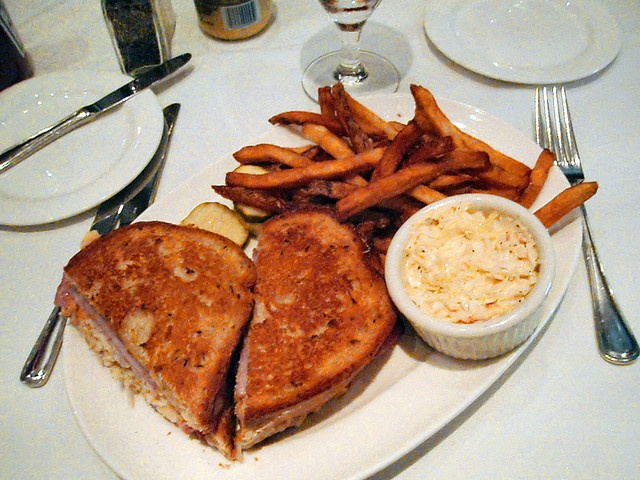Describe the objects in this image and their specific colors. I can see dining table in gray, lightgray, and darkgray tones, sandwich in gray, brown, red, and maroon tones, sandwich in gray, brown, red, and maroon tones, bowl in gray, tan, and lightgray tones, and wine glass in gray, darkgray, lightgray, and tan tones in this image. 